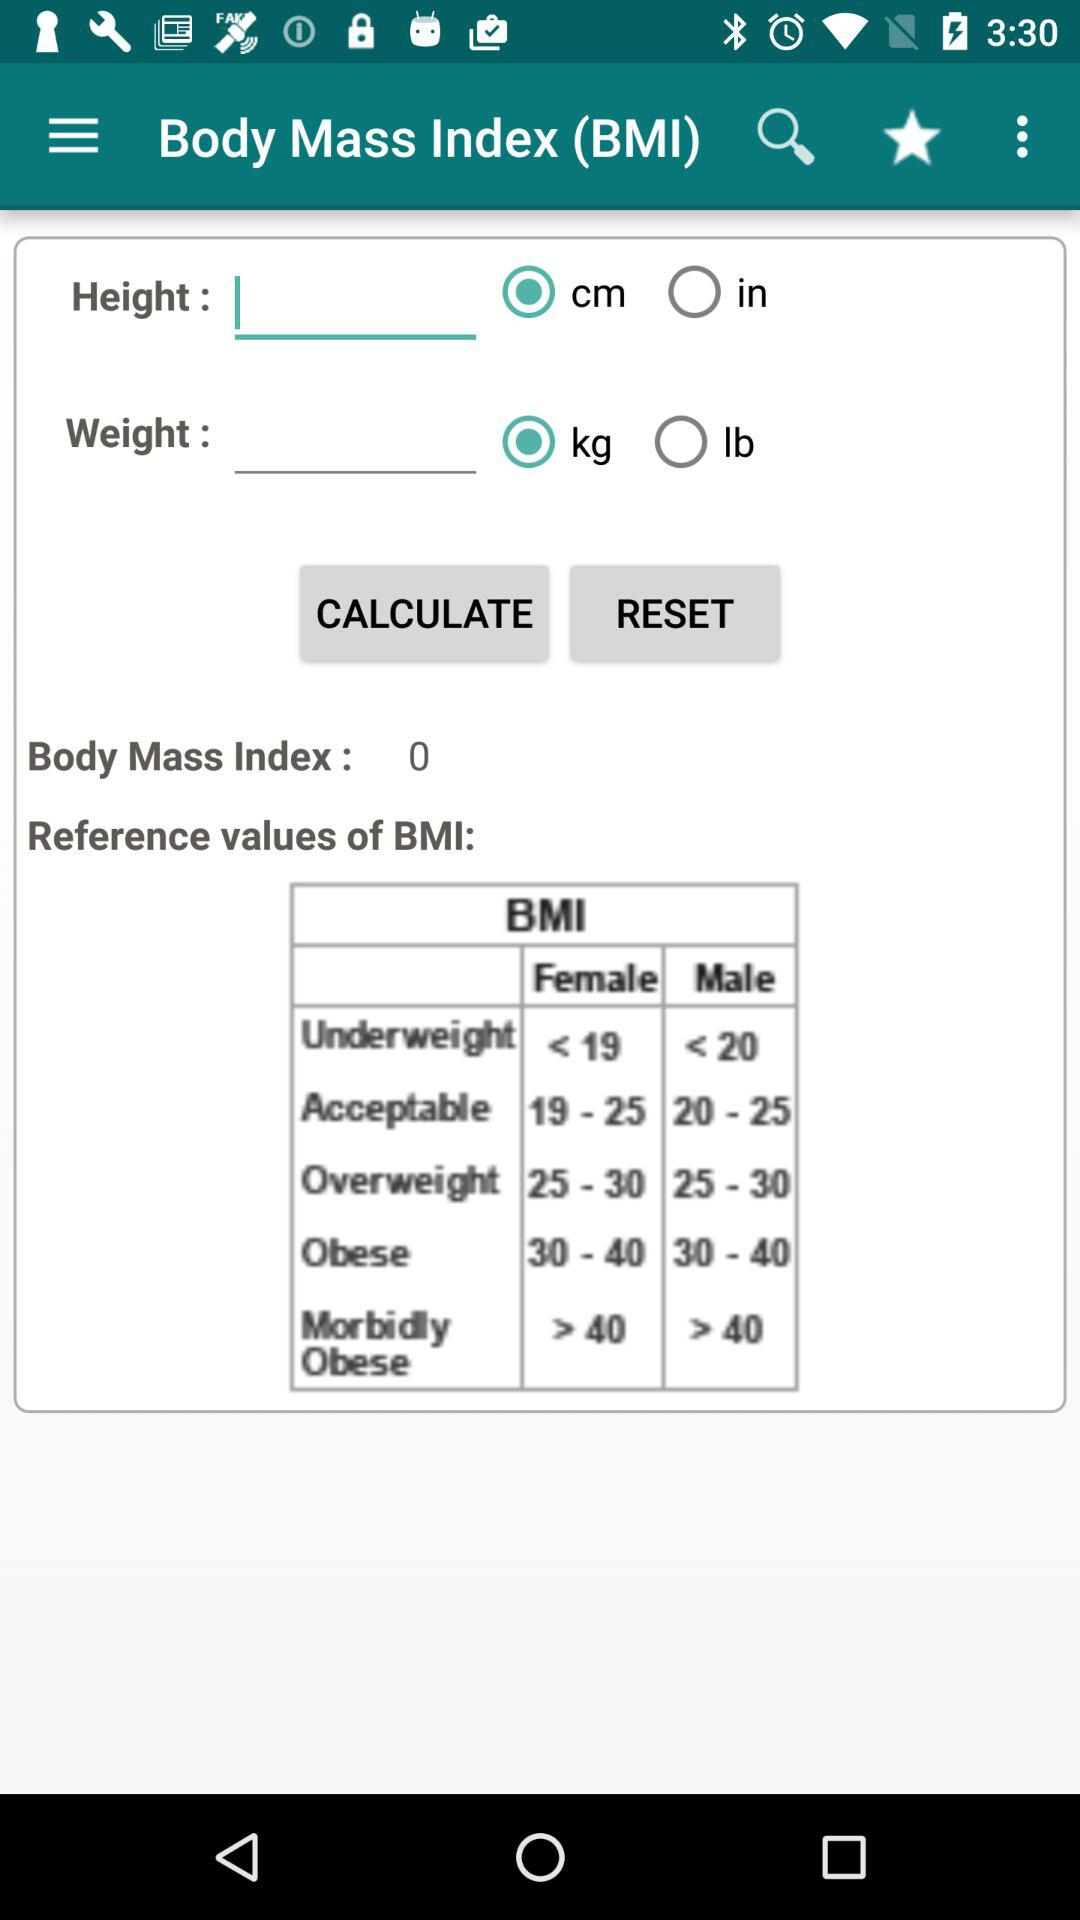Which unit is selected to measure weight? The selected unit is kg. 